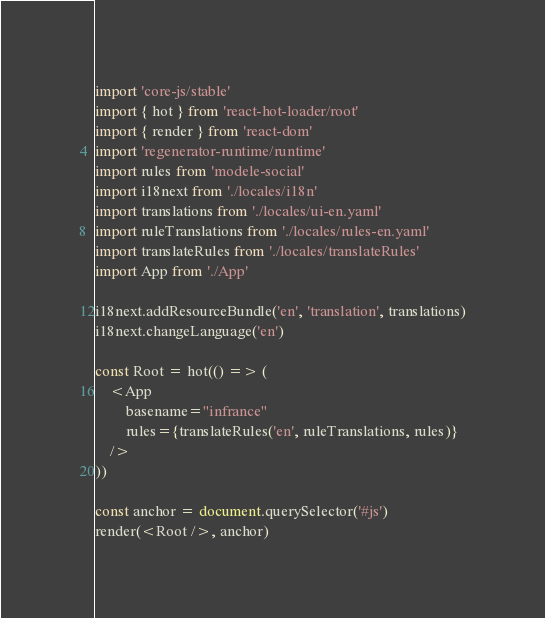<code> <loc_0><loc_0><loc_500><loc_500><_TypeScript_>import 'core-js/stable'
import { hot } from 'react-hot-loader/root'
import { render } from 'react-dom'
import 'regenerator-runtime/runtime'
import rules from 'modele-social'
import i18next from './locales/i18n'
import translations from './locales/ui-en.yaml'
import ruleTranslations from './locales/rules-en.yaml'
import translateRules from './locales/translateRules'
import App from './App'

i18next.addResourceBundle('en', 'translation', translations)
i18next.changeLanguage('en')

const Root = hot(() => (
	<App
		basename="infrance"
		rules={translateRules('en', ruleTranslations, rules)}
	/>
))

const anchor = document.querySelector('#js')
render(<Root />, anchor)
</code> 